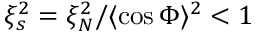<formula> <loc_0><loc_0><loc_500><loc_500>\xi _ { s } ^ { 2 } = \xi _ { N } ^ { 2 } / \langle \cos \Phi \rangle ^ { 2 } < 1</formula> 